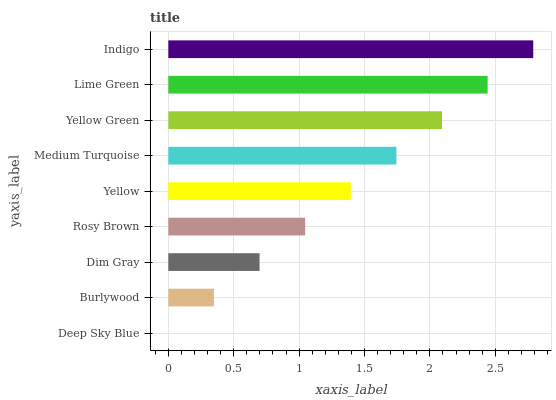Is Deep Sky Blue the minimum?
Answer yes or no. Yes. Is Indigo the maximum?
Answer yes or no. Yes. Is Burlywood the minimum?
Answer yes or no. No. Is Burlywood the maximum?
Answer yes or no. No. Is Burlywood greater than Deep Sky Blue?
Answer yes or no. Yes. Is Deep Sky Blue less than Burlywood?
Answer yes or no. Yes. Is Deep Sky Blue greater than Burlywood?
Answer yes or no. No. Is Burlywood less than Deep Sky Blue?
Answer yes or no. No. Is Yellow the high median?
Answer yes or no. Yes. Is Yellow the low median?
Answer yes or no. Yes. Is Deep Sky Blue the high median?
Answer yes or no. No. Is Indigo the low median?
Answer yes or no. No. 